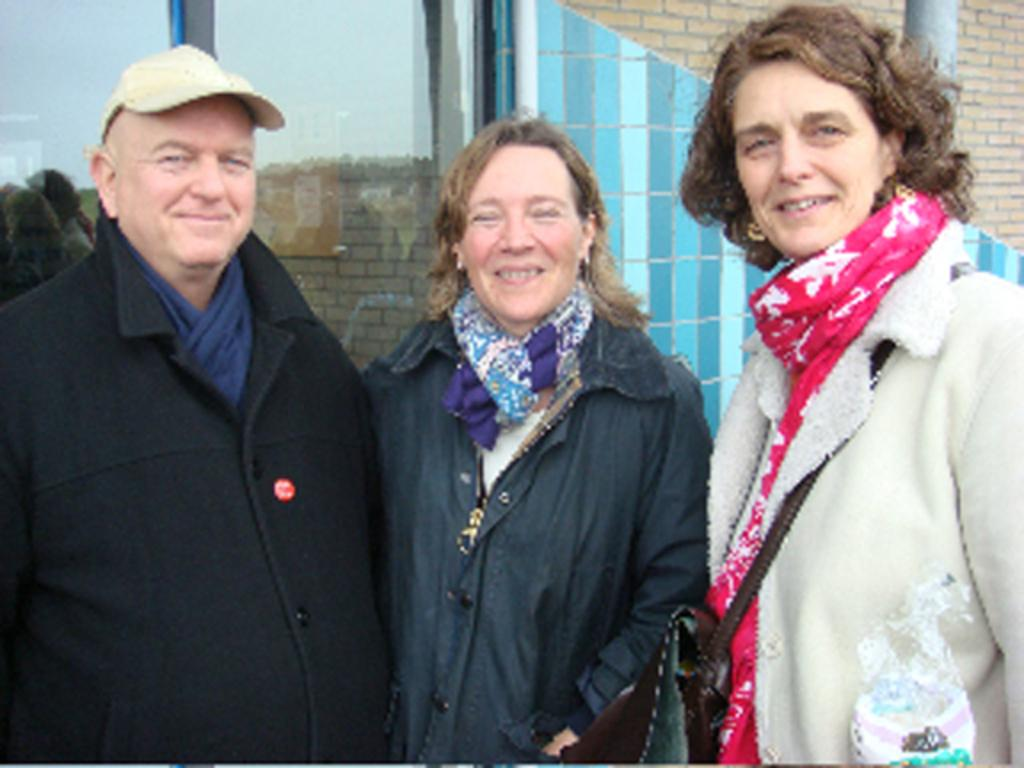How many people are in the image? There are three persons standing in the middle of the image. What are the expressions on the faces of the persons? The persons are smiling. What can be seen in the background of the image? There is a building visible behind the persons. Can you see any cattle grazing near the building in the image? There is no mention of cattle or any animals in the image; it only features three persons standing and a building in the background. 